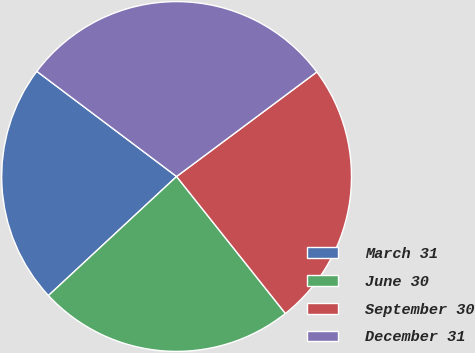<chart> <loc_0><loc_0><loc_500><loc_500><pie_chart><fcel>March 31<fcel>June 30<fcel>September 30<fcel>December 31<nl><fcel>22.18%<fcel>23.77%<fcel>24.51%<fcel>29.54%<nl></chart> 